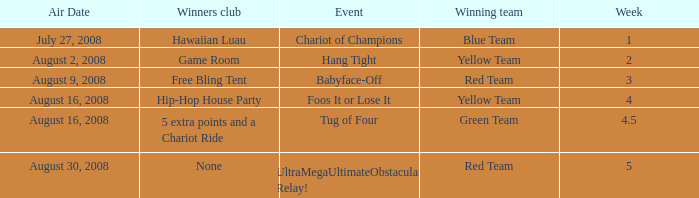How many weeks have a Winning team of yellow team, and an Event of foos it or lose it? 4.0. 